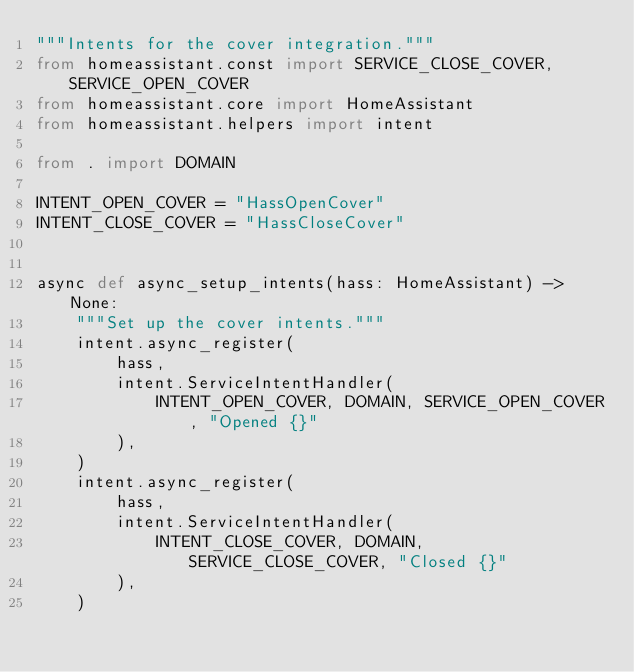<code> <loc_0><loc_0><loc_500><loc_500><_Python_>"""Intents for the cover integration."""
from homeassistant.const import SERVICE_CLOSE_COVER, SERVICE_OPEN_COVER
from homeassistant.core import HomeAssistant
from homeassistant.helpers import intent

from . import DOMAIN

INTENT_OPEN_COVER = "HassOpenCover"
INTENT_CLOSE_COVER = "HassCloseCover"


async def async_setup_intents(hass: HomeAssistant) -> None:
    """Set up the cover intents."""
    intent.async_register(
        hass,
        intent.ServiceIntentHandler(
            INTENT_OPEN_COVER, DOMAIN, SERVICE_OPEN_COVER, "Opened {}"
        ),
    )
    intent.async_register(
        hass,
        intent.ServiceIntentHandler(
            INTENT_CLOSE_COVER, DOMAIN, SERVICE_CLOSE_COVER, "Closed {}"
        ),
    )
</code> 